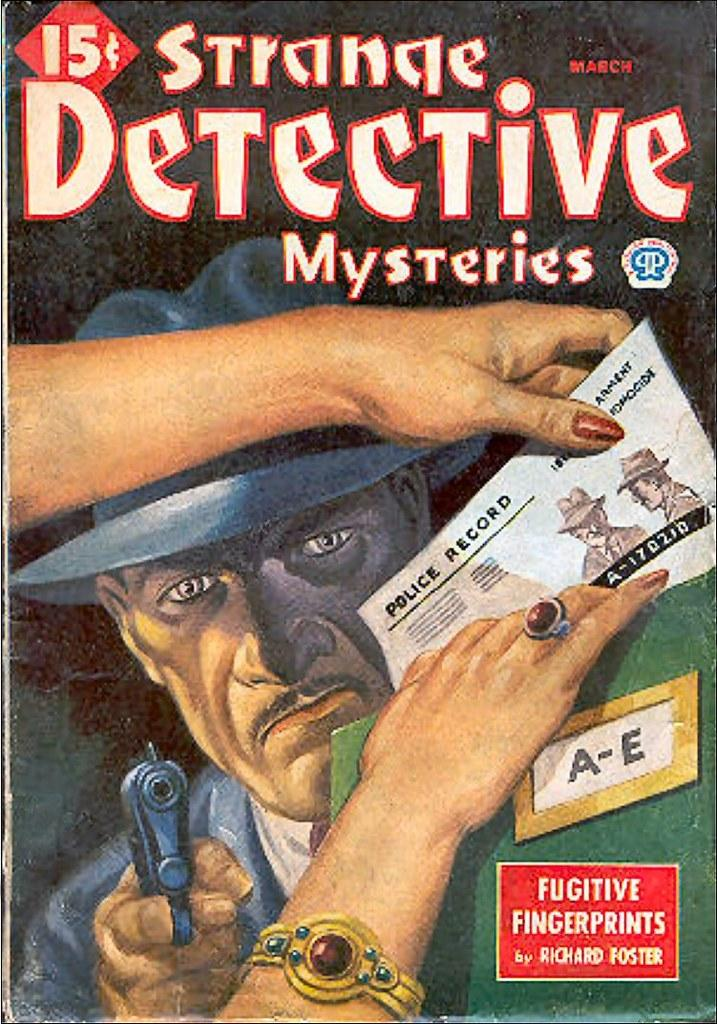<image>
Share a concise interpretation of the image provided. A comic book cover of the Strange Detective Mysteries 